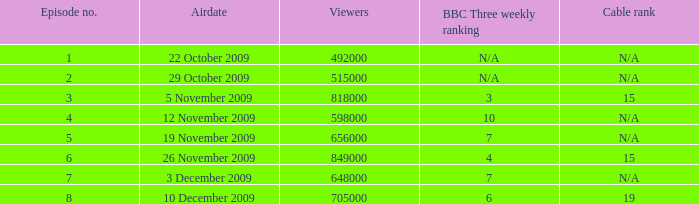What is the cable rank for bbc three weekly ranking of n/a? N/A, N/A. 